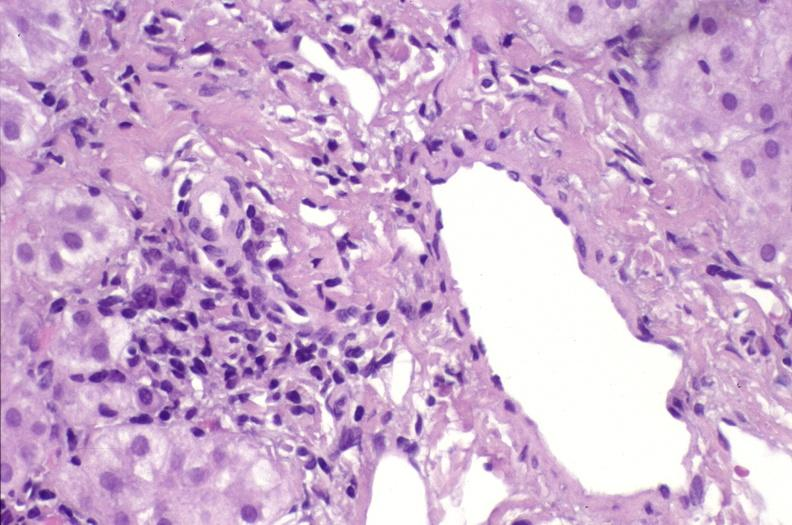what is present?
Answer the question using a single word or phrase. Liver 